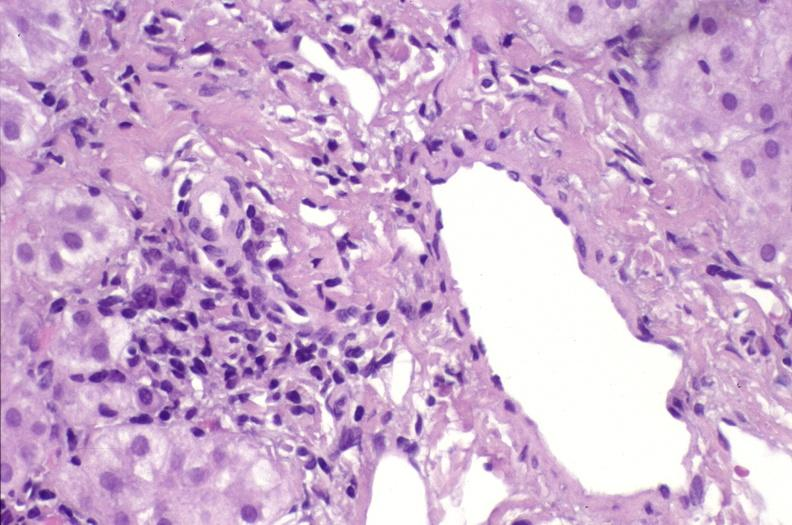what is present?
Answer the question using a single word or phrase. Liver 